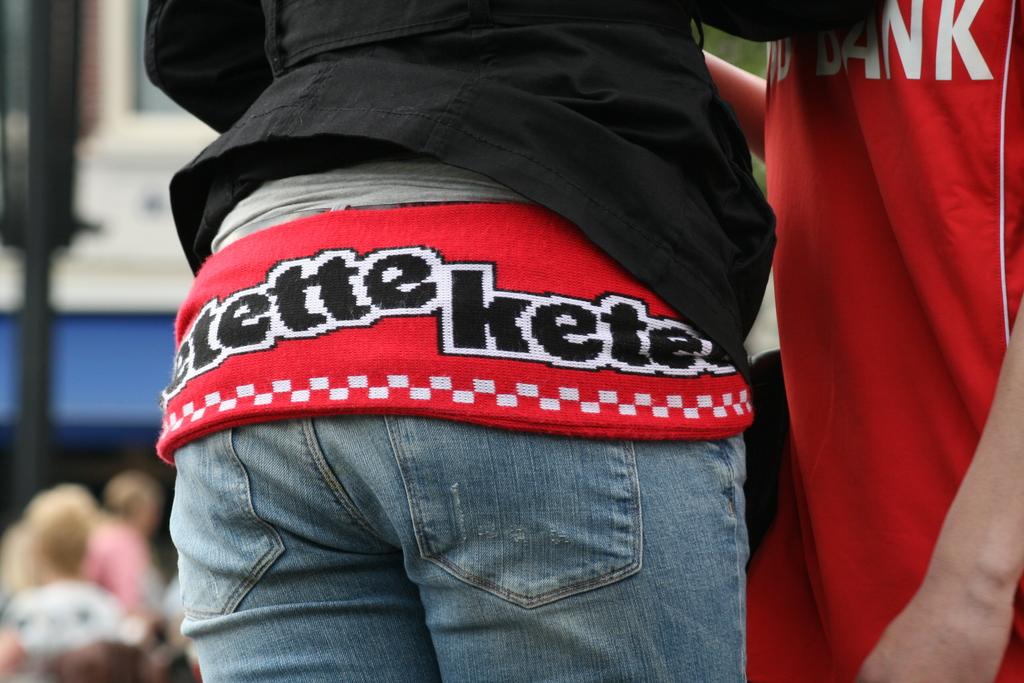What is written on this shirt?
Provide a short and direct response. Etette kete. What is written on her belt?
Your answer should be very brief. Etette kete. 